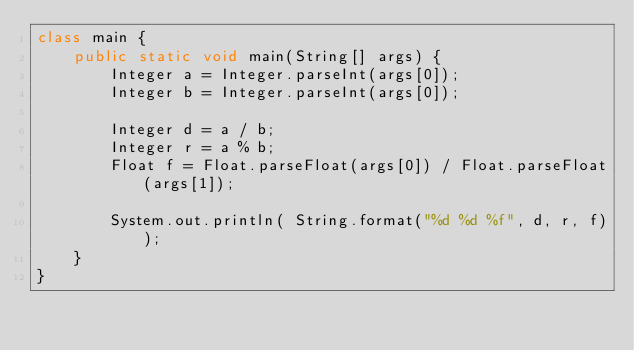Convert code to text. <code><loc_0><loc_0><loc_500><loc_500><_Java_>class main {
    public static void main(String[] args) {
        Integer a = Integer.parseInt(args[0]);
        Integer b = Integer.parseInt(args[0]);

        Integer d = a / b;
        Integer r = a % b;
        Float f = Float.parseFloat(args[0]) / Float.parseFloat(args[1]);

        System.out.println( String.format("%d %d %f", d, r, f));
    }
}</code> 